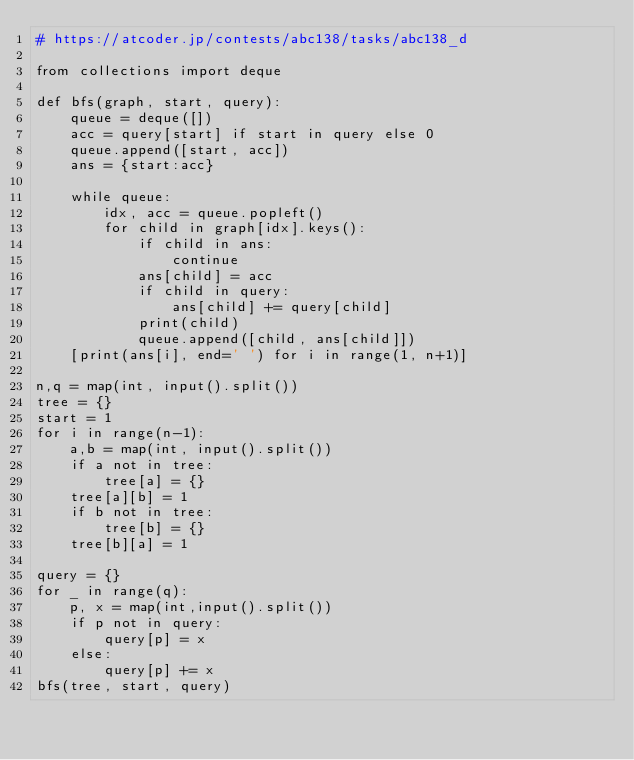Convert code to text. <code><loc_0><loc_0><loc_500><loc_500><_Python_># https://atcoder.jp/contests/abc138/tasks/abc138_d

from collections import deque

def bfs(graph, start, query):
    queue = deque([])
    acc = query[start] if start in query else 0
    queue.append([start, acc])
    ans = {start:acc}

    while queue:
        idx, acc = queue.popleft()
        for child in graph[idx].keys():
            if child in ans:
                continue
            ans[child] = acc
            if child in query:
                ans[child] += query[child]
            print(child)
            queue.append([child, ans[child]])
    [print(ans[i], end=' ') for i in range(1, n+1)]

n,q = map(int, input().split())
tree = {}
start = 1
for i in range(n-1):
    a,b = map(int, input().split())
    if a not in tree:
        tree[a] = {}
    tree[a][b] = 1
    if b not in tree:
        tree[b] = {}
    tree[b][a] = 1

query = {}
for _ in range(q):
    p, x = map(int,input().split())
    if p not in query:
        query[p] = x
    else:
        query[p] += x
bfs(tree, start, query)
</code> 